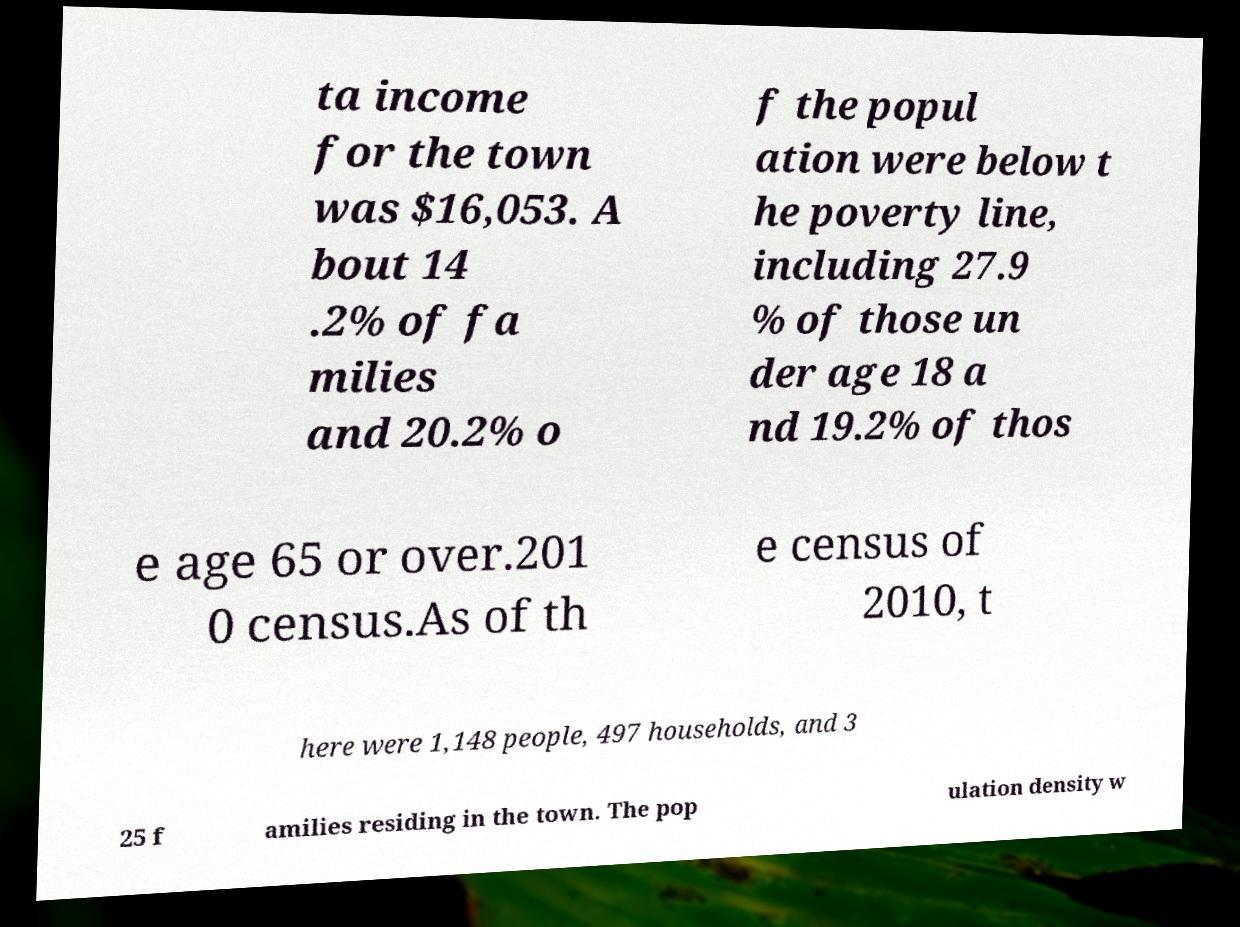Could you assist in decoding the text presented in this image and type it out clearly? ta income for the town was $16,053. A bout 14 .2% of fa milies and 20.2% o f the popul ation were below t he poverty line, including 27.9 % of those un der age 18 a nd 19.2% of thos e age 65 or over.201 0 census.As of th e census of 2010, t here were 1,148 people, 497 households, and 3 25 f amilies residing in the town. The pop ulation density w 